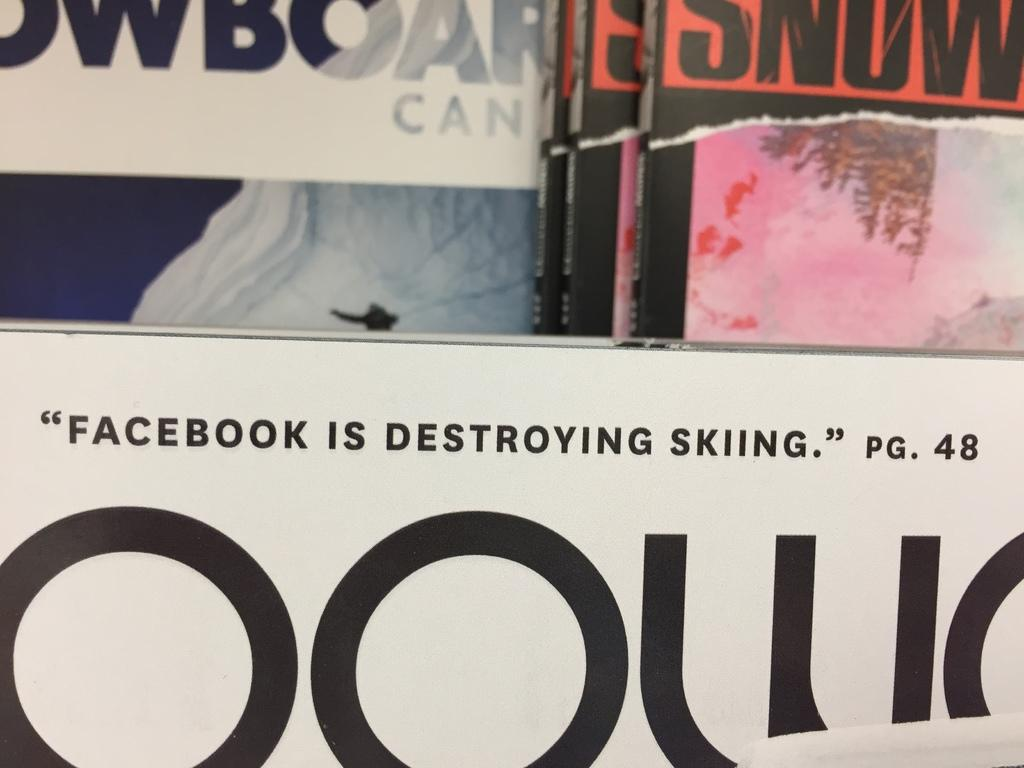Provide a one-sentence caption for the provided image. An issue of Snow magazine has an articled entitled Facebook is Destroying Skiing. 